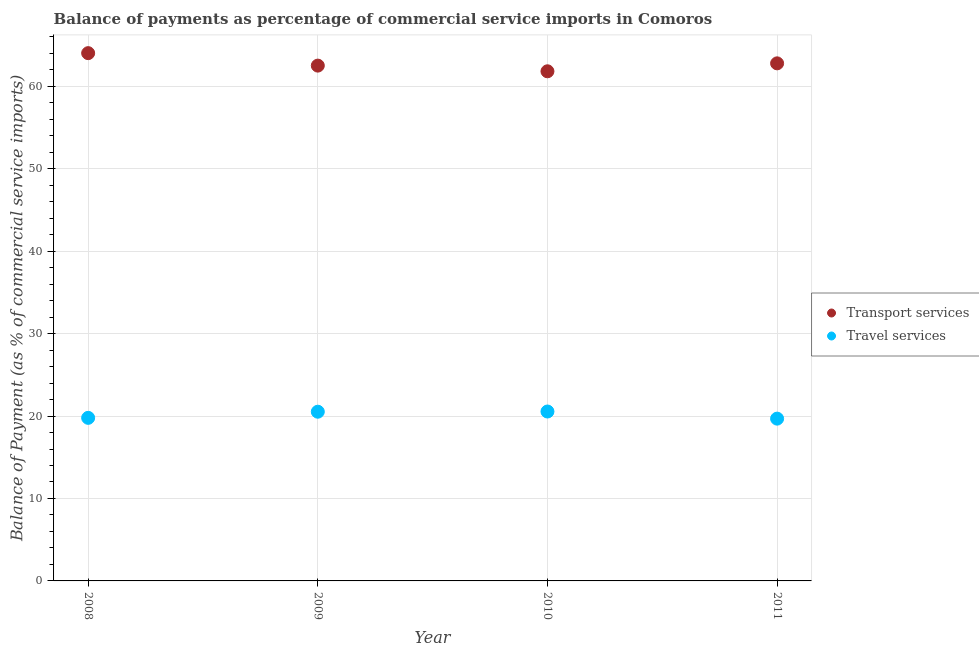What is the balance of payments of transport services in 2011?
Make the answer very short. 62.78. Across all years, what is the maximum balance of payments of transport services?
Make the answer very short. 64.02. Across all years, what is the minimum balance of payments of travel services?
Provide a succinct answer. 19.68. What is the total balance of payments of transport services in the graph?
Your response must be concise. 251.12. What is the difference between the balance of payments of travel services in 2008 and that in 2010?
Provide a succinct answer. -0.77. What is the difference between the balance of payments of travel services in 2010 and the balance of payments of transport services in 2008?
Your response must be concise. -43.47. What is the average balance of payments of travel services per year?
Offer a terse response. 20.13. In the year 2011, what is the difference between the balance of payments of transport services and balance of payments of travel services?
Make the answer very short. 43.1. What is the ratio of the balance of payments of transport services in 2009 to that in 2010?
Provide a succinct answer. 1.01. Is the difference between the balance of payments of transport services in 2009 and 2010 greater than the difference between the balance of payments of travel services in 2009 and 2010?
Your answer should be very brief. Yes. What is the difference between the highest and the second highest balance of payments of travel services?
Give a very brief answer. 0.02. What is the difference between the highest and the lowest balance of payments of transport services?
Provide a succinct answer. 2.2. In how many years, is the balance of payments of transport services greater than the average balance of payments of transport services taken over all years?
Provide a short and direct response. 2. Does the balance of payments of travel services monotonically increase over the years?
Provide a succinct answer. No. Is the balance of payments of travel services strictly less than the balance of payments of transport services over the years?
Provide a succinct answer. Yes. How many dotlines are there?
Make the answer very short. 2. What is the difference between two consecutive major ticks on the Y-axis?
Provide a short and direct response. 10. Does the graph contain grids?
Offer a terse response. Yes. Where does the legend appear in the graph?
Make the answer very short. Center right. How many legend labels are there?
Make the answer very short. 2. What is the title of the graph?
Ensure brevity in your answer.  Balance of payments as percentage of commercial service imports in Comoros. Does "Females" appear as one of the legend labels in the graph?
Make the answer very short. No. What is the label or title of the X-axis?
Your answer should be very brief. Year. What is the label or title of the Y-axis?
Your answer should be compact. Balance of Payment (as % of commercial service imports). What is the Balance of Payment (as % of commercial service imports) in Transport services in 2008?
Your answer should be compact. 64.02. What is the Balance of Payment (as % of commercial service imports) in Travel services in 2008?
Offer a terse response. 19.78. What is the Balance of Payment (as % of commercial service imports) of Transport services in 2009?
Give a very brief answer. 62.51. What is the Balance of Payment (as % of commercial service imports) of Travel services in 2009?
Give a very brief answer. 20.52. What is the Balance of Payment (as % of commercial service imports) in Transport services in 2010?
Your response must be concise. 61.82. What is the Balance of Payment (as % of commercial service imports) in Travel services in 2010?
Offer a very short reply. 20.55. What is the Balance of Payment (as % of commercial service imports) in Transport services in 2011?
Keep it short and to the point. 62.78. What is the Balance of Payment (as % of commercial service imports) in Travel services in 2011?
Your answer should be compact. 19.68. Across all years, what is the maximum Balance of Payment (as % of commercial service imports) in Transport services?
Give a very brief answer. 64.02. Across all years, what is the maximum Balance of Payment (as % of commercial service imports) of Travel services?
Offer a terse response. 20.55. Across all years, what is the minimum Balance of Payment (as % of commercial service imports) in Transport services?
Provide a short and direct response. 61.82. Across all years, what is the minimum Balance of Payment (as % of commercial service imports) in Travel services?
Your answer should be very brief. 19.68. What is the total Balance of Payment (as % of commercial service imports) in Transport services in the graph?
Offer a terse response. 251.12. What is the total Balance of Payment (as % of commercial service imports) in Travel services in the graph?
Offer a terse response. 80.54. What is the difference between the Balance of Payment (as % of commercial service imports) of Transport services in 2008 and that in 2009?
Your answer should be very brief. 1.51. What is the difference between the Balance of Payment (as % of commercial service imports) in Travel services in 2008 and that in 2009?
Provide a succinct answer. -0.74. What is the difference between the Balance of Payment (as % of commercial service imports) of Transport services in 2008 and that in 2010?
Your response must be concise. 2.2. What is the difference between the Balance of Payment (as % of commercial service imports) of Travel services in 2008 and that in 2010?
Provide a short and direct response. -0.77. What is the difference between the Balance of Payment (as % of commercial service imports) in Transport services in 2008 and that in 2011?
Your answer should be compact. 1.24. What is the difference between the Balance of Payment (as % of commercial service imports) in Travel services in 2008 and that in 2011?
Give a very brief answer. 0.1. What is the difference between the Balance of Payment (as % of commercial service imports) in Transport services in 2009 and that in 2010?
Offer a terse response. 0.69. What is the difference between the Balance of Payment (as % of commercial service imports) of Travel services in 2009 and that in 2010?
Give a very brief answer. -0.02. What is the difference between the Balance of Payment (as % of commercial service imports) of Transport services in 2009 and that in 2011?
Your answer should be very brief. -0.27. What is the difference between the Balance of Payment (as % of commercial service imports) of Travel services in 2009 and that in 2011?
Ensure brevity in your answer.  0.84. What is the difference between the Balance of Payment (as % of commercial service imports) in Transport services in 2010 and that in 2011?
Give a very brief answer. -0.96. What is the difference between the Balance of Payment (as % of commercial service imports) of Travel services in 2010 and that in 2011?
Your answer should be very brief. 0.86. What is the difference between the Balance of Payment (as % of commercial service imports) in Transport services in 2008 and the Balance of Payment (as % of commercial service imports) in Travel services in 2009?
Keep it short and to the point. 43.49. What is the difference between the Balance of Payment (as % of commercial service imports) of Transport services in 2008 and the Balance of Payment (as % of commercial service imports) of Travel services in 2010?
Give a very brief answer. 43.47. What is the difference between the Balance of Payment (as % of commercial service imports) of Transport services in 2008 and the Balance of Payment (as % of commercial service imports) of Travel services in 2011?
Provide a succinct answer. 44.33. What is the difference between the Balance of Payment (as % of commercial service imports) of Transport services in 2009 and the Balance of Payment (as % of commercial service imports) of Travel services in 2010?
Offer a terse response. 41.96. What is the difference between the Balance of Payment (as % of commercial service imports) of Transport services in 2009 and the Balance of Payment (as % of commercial service imports) of Travel services in 2011?
Your answer should be very brief. 42.82. What is the difference between the Balance of Payment (as % of commercial service imports) in Transport services in 2010 and the Balance of Payment (as % of commercial service imports) in Travel services in 2011?
Ensure brevity in your answer.  42.13. What is the average Balance of Payment (as % of commercial service imports) in Transport services per year?
Keep it short and to the point. 62.78. What is the average Balance of Payment (as % of commercial service imports) in Travel services per year?
Give a very brief answer. 20.13. In the year 2008, what is the difference between the Balance of Payment (as % of commercial service imports) in Transport services and Balance of Payment (as % of commercial service imports) in Travel services?
Your answer should be very brief. 44.24. In the year 2009, what is the difference between the Balance of Payment (as % of commercial service imports) of Transport services and Balance of Payment (as % of commercial service imports) of Travel services?
Your answer should be very brief. 41.98. In the year 2010, what is the difference between the Balance of Payment (as % of commercial service imports) in Transport services and Balance of Payment (as % of commercial service imports) in Travel services?
Keep it short and to the point. 41.27. In the year 2011, what is the difference between the Balance of Payment (as % of commercial service imports) in Transport services and Balance of Payment (as % of commercial service imports) in Travel services?
Keep it short and to the point. 43.1. What is the ratio of the Balance of Payment (as % of commercial service imports) of Transport services in 2008 to that in 2009?
Your answer should be compact. 1.02. What is the ratio of the Balance of Payment (as % of commercial service imports) of Travel services in 2008 to that in 2009?
Your answer should be very brief. 0.96. What is the ratio of the Balance of Payment (as % of commercial service imports) of Transport services in 2008 to that in 2010?
Your answer should be very brief. 1.04. What is the ratio of the Balance of Payment (as % of commercial service imports) of Travel services in 2008 to that in 2010?
Offer a very short reply. 0.96. What is the ratio of the Balance of Payment (as % of commercial service imports) in Transport services in 2008 to that in 2011?
Your answer should be compact. 1.02. What is the ratio of the Balance of Payment (as % of commercial service imports) of Travel services in 2008 to that in 2011?
Your response must be concise. 1. What is the ratio of the Balance of Payment (as % of commercial service imports) in Transport services in 2009 to that in 2010?
Your answer should be very brief. 1.01. What is the ratio of the Balance of Payment (as % of commercial service imports) in Travel services in 2009 to that in 2010?
Provide a short and direct response. 1. What is the ratio of the Balance of Payment (as % of commercial service imports) of Transport services in 2009 to that in 2011?
Your answer should be very brief. 1. What is the ratio of the Balance of Payment (as % of commercial service imports) in Travel services in 2009 to that in 2011?
Give a very brief answer. 1.04. What is the ratio of the Balance of Payment (as % of commercial service imports) of Transport services in 2010 to that in 2011?
Keep it short and to the point. 0.98. What is the ratio of the Balance of Payment (as % of commercial service imports) of Travel services in 2010 to that in 2011?
Make the answer very short. 1.04. What is the difference between the highest and the second highest Balance of Payment (as % of commercial service imports) of Transport services?
Keep it short and to the point. 1.24. What is the difference between the highest and the second highest Balance of Payment (as % of commercial service imports) in Travel services?
Provide a succinct answer. 0.02. What is the difference between the highest and the lowest Balance of Payment (as % of commercial service imports) in Transport services?
Offer a terse response. 2.2. What is the difference between the highest and the lowest Balance of Payment (as % of commercial service imports) in Travel services?
Your answer should be very brief. 0.86. 